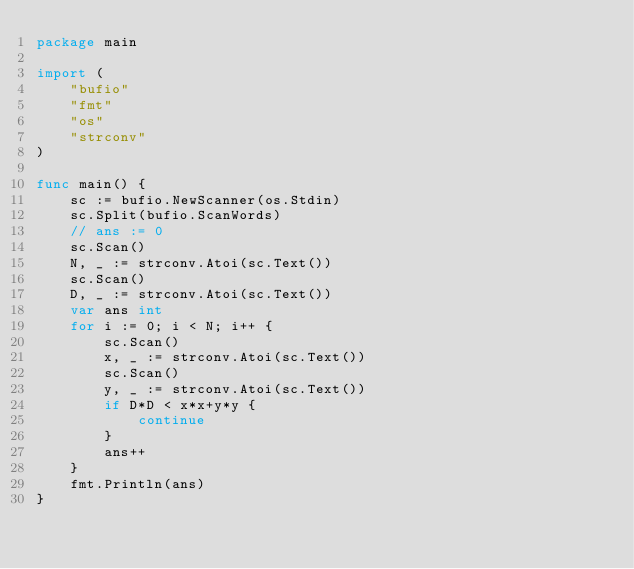Convert code to text. <code><loc_0><loc_0><loc_500><loc_500><_Go_>package main

import (
	"bufio"
	"fmt"
	"os"
	"strconv"
)

func main() {
	sc := bufio.NewScanner(os.Stdin)
	sc.Split(bufio.ScanWords)
	// ans := 0
	sc.Scan()
	N, _ := strconv.Atoi(sc.Text())
	sc.Scan()
	D, _ := strconv.Atoi(sc.Text())
	var ans int
	for i := 0; i < N; i++ {
		sc.Scan()
		x, _ := strconv.Atoi(sc.Text())
		sc.Scan()
		y, _ := strconv.Atoi(sc.Text())
		if D*D < x*x+y*y {
			continue
		}
		ans++
	}
	fmt.Println(ans)
}
</code> 